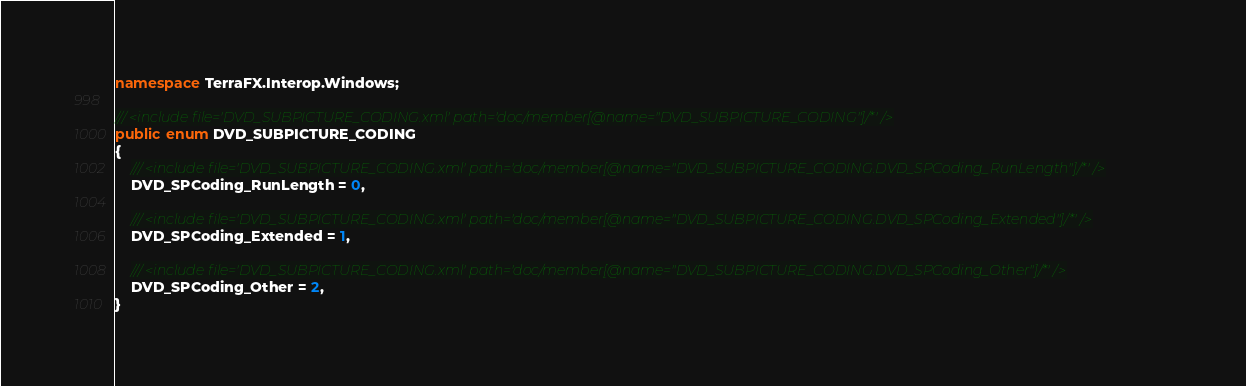<code> <loc_0><loc_0><loc_500><loc_500><_C#_>namespace TerraFX.Interop.Windows;

/// <include file='DVD_SUBPICTURE_CODING.xml' path='doc/member[@name="DVD_SUBPICTURE_CODING"]/*' />
public enum DVD_SUBPICTURE_CODING
{
    /// <include file='DVD_SUBPICTURE_CODING.xml' path='doc/member[@name="DVD_SUBPICTURE_CODING.DVD_SPCoding_RunLength"]/*' />
    DVD_SPCoding_RunLength = 0,

    /// <include file='DVD_SUBPICTURE_CODING.xml' path='doc/member[@name="DVD_SUBPICTURE_CODING.DVD_SPCoding_Extended"]/*' />
    DVD_SPCoding_Extended = 1,

    /// <include file='DVD_SUBPICTURE_CODING.xml' path='doc/member[@name="DVD_SUBPICTURE_CODING.DVD_SPCoding_Other"]/*' />
    DVD_SPCoding_Other = 2,
}
</code> 